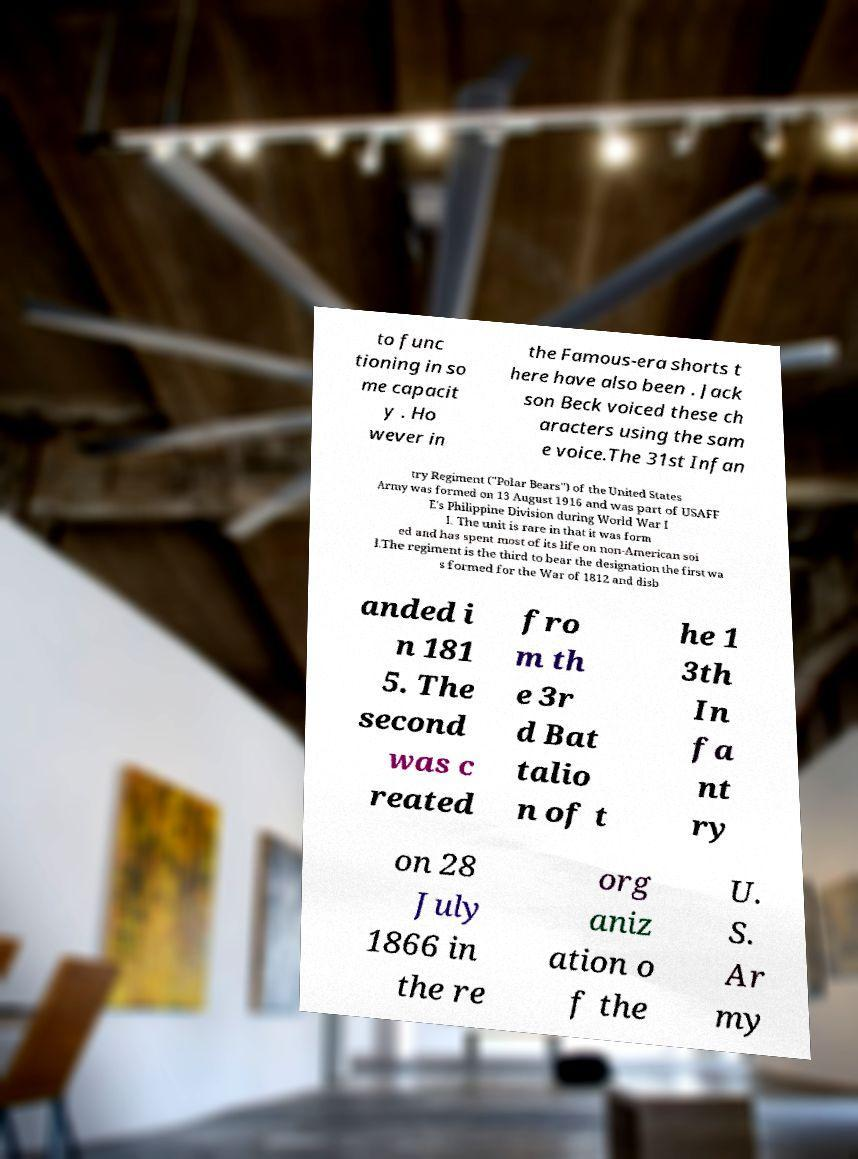I need the written content from this picture converted into text. Can you do that? to func tioning in so me capacit y . Ho wever in the Famous-era shorts t here have also been . Jack son Beck voiced these ch aracters using the sam e voice.The 31st Infan try Regiment ("Polar Bears") of the United States Army was formed on 13 August 1916 and was part of USAFF E's Philippine Division during World War I I. The unit is rare in that it was form ed and has spent most of its life on non-American soi l.The regiment is the third to bear the designation the first wa s formed for the War of 1812 and disb anded i n 181 5. The second was c reated fro m th e 3r d Bat talio n of t he 1 3th In fa nt ry on 28 July 1866 in the re org aniz ation o f the U. S. Ar my 